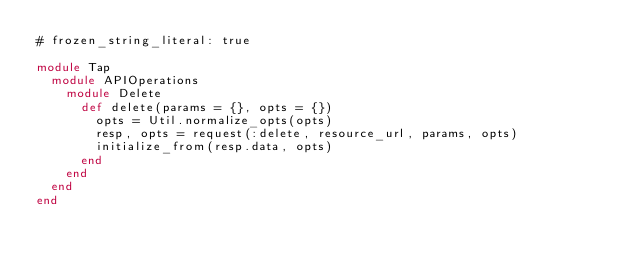Convert code to text. <code><loc_0><loc_0><loc_500><loc_500><_Ruby_># frozen_string_literal: true

module Tap
  module APIOperations
    module Delete
      def delete(params = {}, opts = {})
        opts = Util.normalize_opts(opts)
        resp, opts = request(:delete, resource_url, params, opts)
        initialize_from(resp.data, opts)
      end
    end
  end
end
</code> 